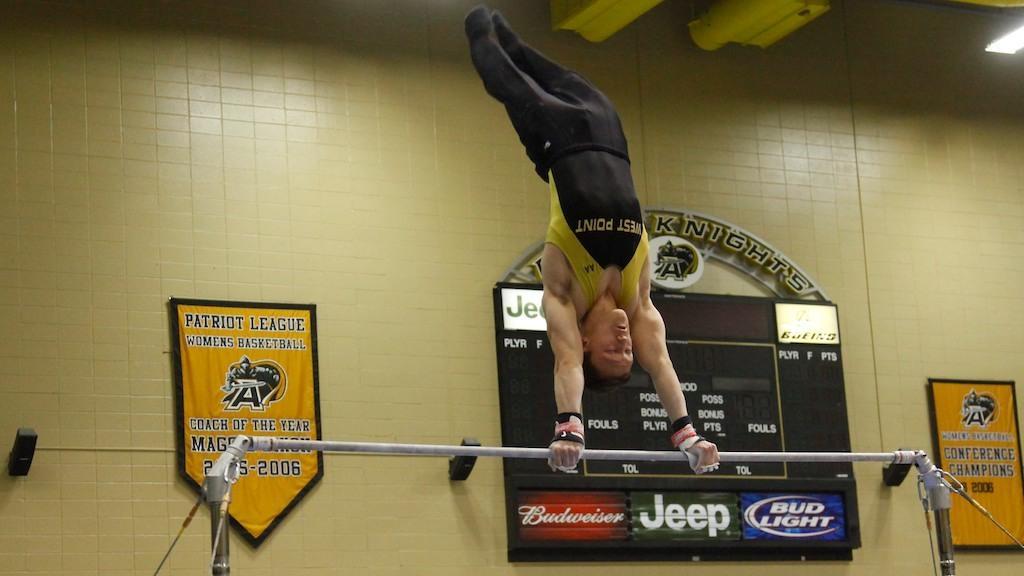How would you summarize this image in a sentence or two? In this picture I can see there is a man, he is performing gymnastics and he is holding a hand. In the backdrop I can see there is a wall and there are some banners and boards attached to the wall. 